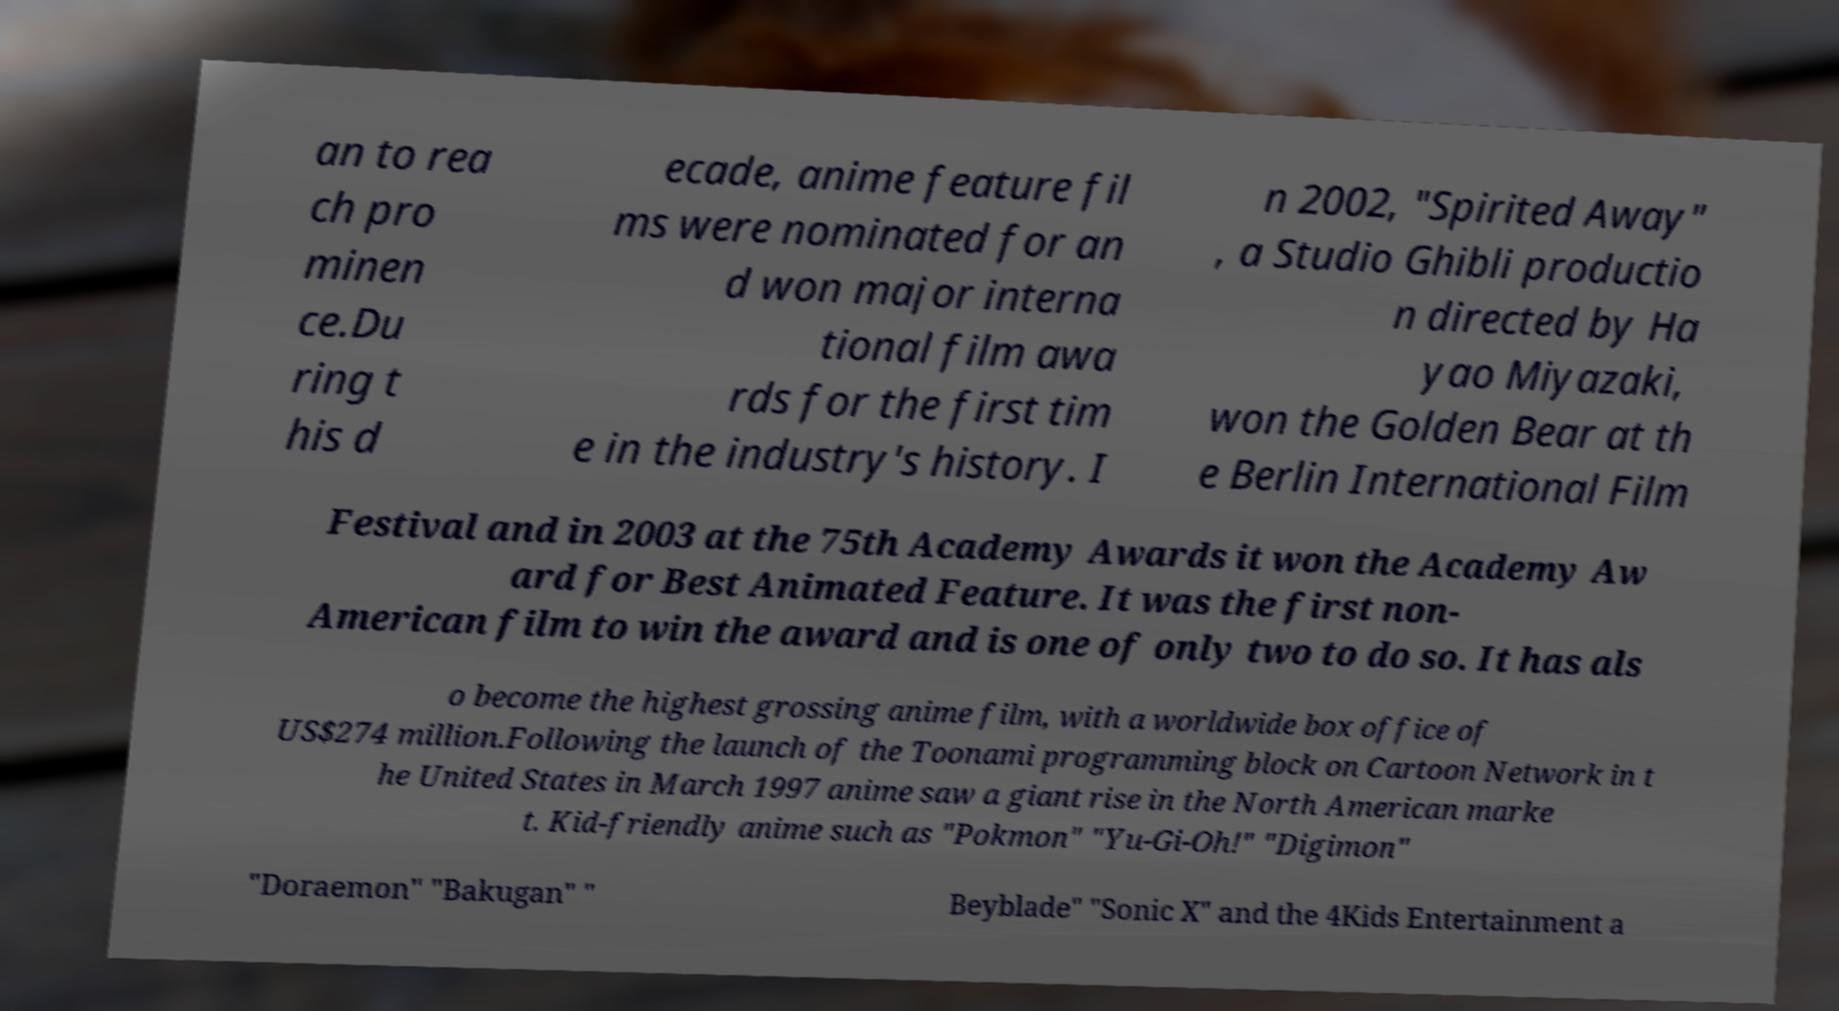Please identify and transcribe the text found in this image. an to rea ch pro minen ce.Du ring t his d ecade, anime feature fil ms were nominated for an d won major interna tional film awa rds for the first tim e in the industry's history. I n 2002, "Spirited Away" , a Studio Ghibli productio n directed by Ha yao Miyazaki, won the Golden Bear at th e Berlin International Film Festival and in 2003 at the 75th Academy Awards it won the Academy Aw ard for Best Animated Feature. It was the first non- American film to win the award and is one of only two to do so. It has als o become the highest grossing anime film, with a worldwide box office of US$274 million.Following the launch of the Toonami programming block on Cartoon Network in t he United States in March 1997 anime saw a giant rise in the North American marke t. Kid-friendly anime such as "Pokmon" "Yu-Gi-Oh!" "Digimon" "Doraemon" "Bakugan" " Beyblade" "Sonic X" and the 4Kids Entertainment a 